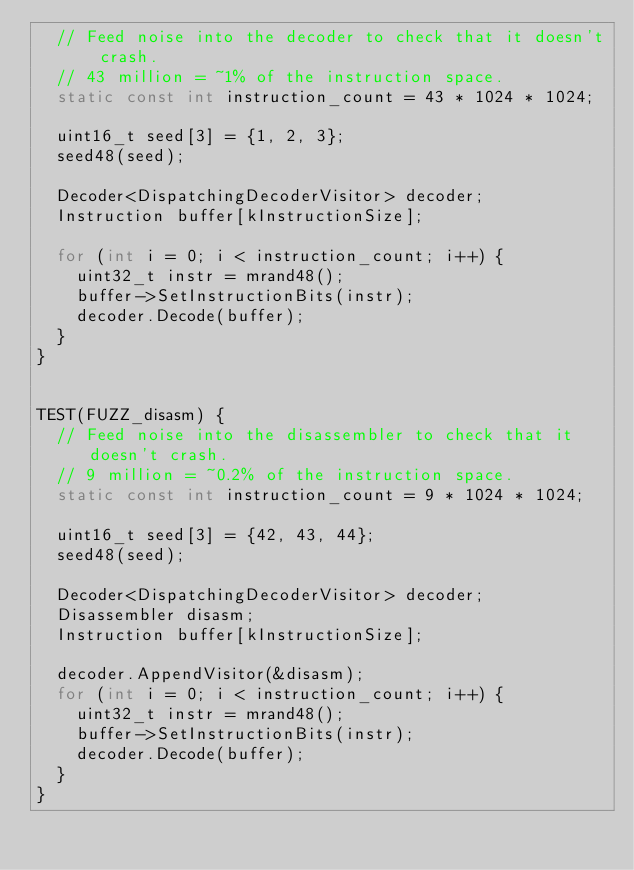Convert code to text. <code><loc_0><loc_0><loc_500><loc_500><_C++_>  // Feed noise into the decoder to check that it doesn't crash.
  // 43 million = ~1% of the instruction space.
  static const int instruction_count = 43 * 1024 * 1024;

  uint16_t seed[3] = {1, 2, 3};
  seed48(seed);

  Decoder<DispatchingDecoderVisitor> decoder;
  Instruction buffer[kInstructionSize];

  for (int i = 0; i < instruction_count; i++) {
    uint32_t instr = mrand48();
    buffer->SetInstructionBits(instr);
    decoder.Decode(buffer);
  }
}


TEST(FUZZ_disasm) {
  // Feed noise into the disassembler to check that it doesn't crash.
  // 9 million = ~0.2% of the instruction space.
  static const int instruction_count = 9 * 1024 * 1024;

  uint16_t seed[3] = {42, 43, 44};
  seed48(seed);

  Decoder<DispatchingDecoderVisitor> decoder;
  Disassembler disasm;
  Instruction buffer[kInstructionSize];

  decoder.AppendVisitor(&disasm);
  for (int i = 0; i < instruction_count; i++) {
    uint32_t instr = mrand48();
    buffer->SetInstructionBits(instr);
    decoder.Decode(buffer);
  }
}
</code> 